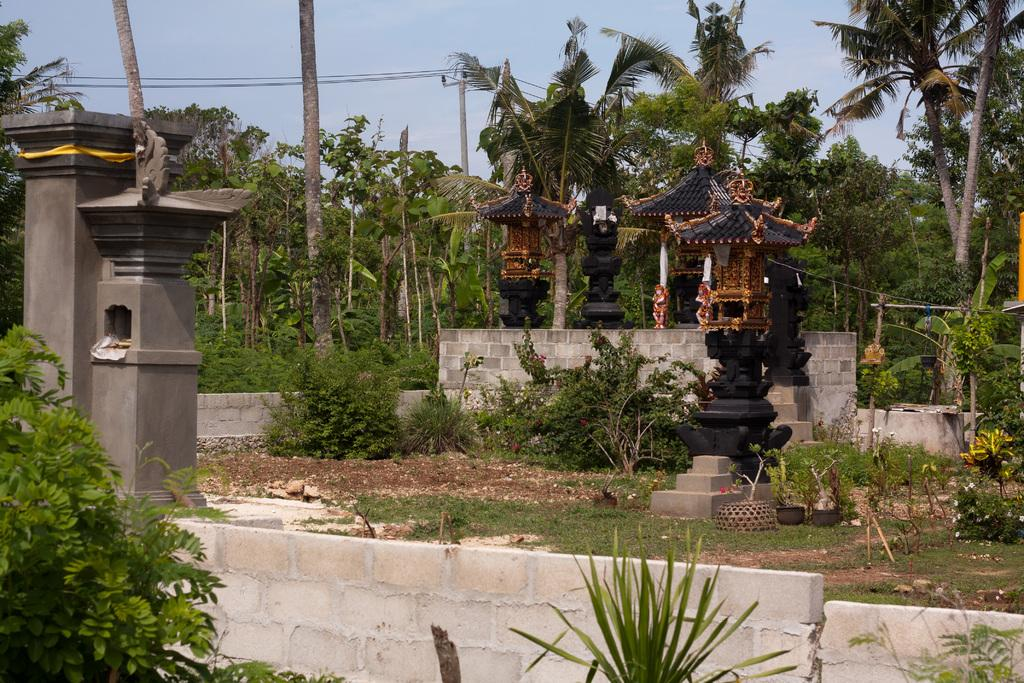What type of vegetation can be seen in the image? There are trees and plants visible in the image. What structures are present in the image? There are poles with wires attached, a wall fence, and pillars in the image. What is the ground covered with in the image? The grass is visible in the image. What can be seen in the background of the image? The sky is visible in the background of the image. What type of brake is installed on the trees in the image? There is no brake present in the image; it features trees, poles with wires, plants, grass, a wall fence, pillars, and the sky. What type of stew is being prepared on the pillars in the image? There is no stew or cooking activity present in the image; it only shows the mentioned objects and the sky. 